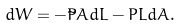Convert formula to latex. <formula><loc_0><loc_0><loc_500><loc_500>d W = - \tilde { P } A d L - P L d A .</formula> 